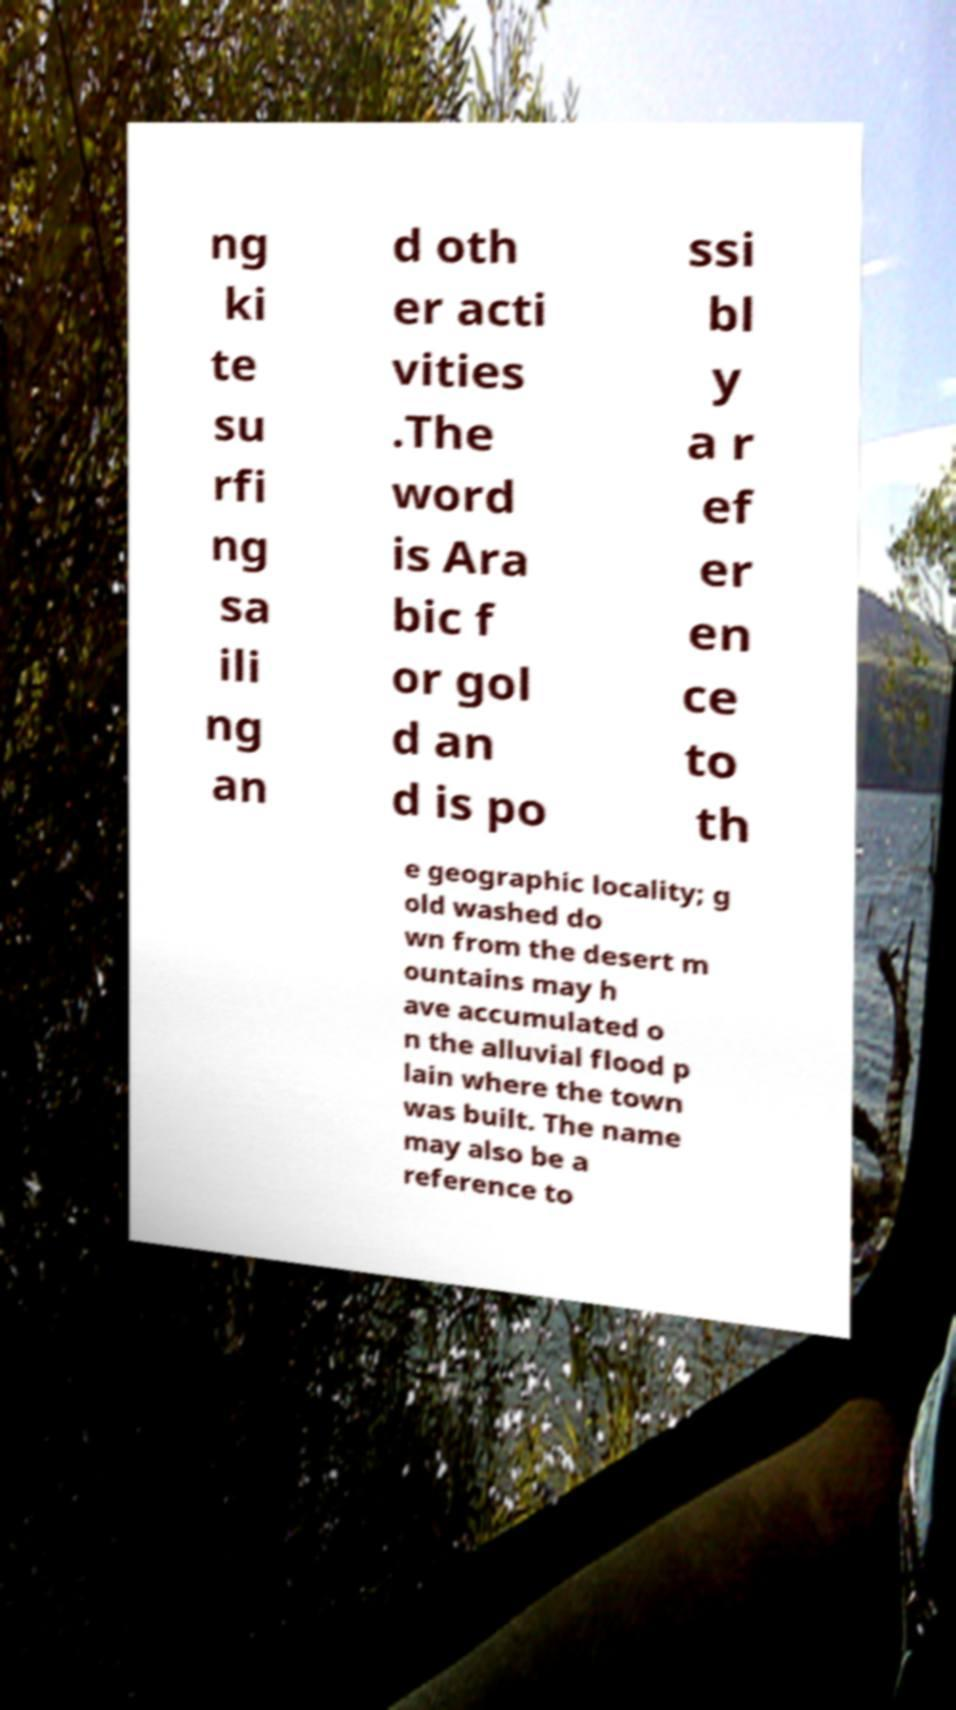Please identify and transcribe the text found in this image. ng ki te su rfi ng sa ili ng an d oth er acti vities .The word is Ara bic f or gol d an d is po ssi bl y a r ef er en ce to th e geographic locality; g old washed do wn from the desert m ountains may h ave accumulated o n the alluvial flood p lain where the town was built. The name may also be a reference to 